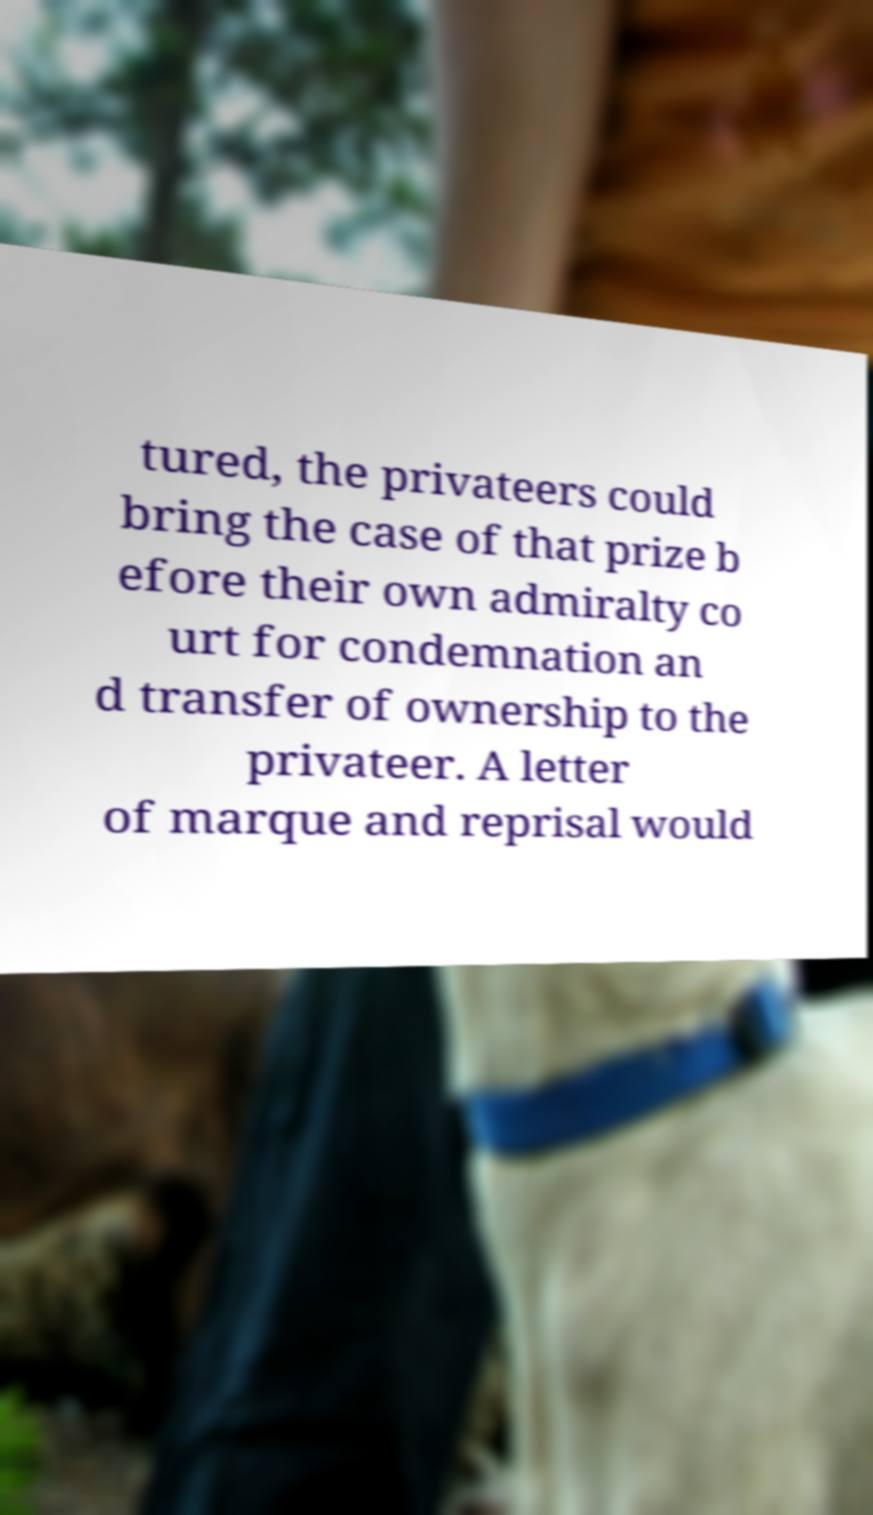Please read and relay the text visible in this image. What does it say? tured, the privateers could bring the case of that prize b efore their own admiralty co urt for condemnation an d transfer of ownership to the privateer. A letter of marque and reprisal would 